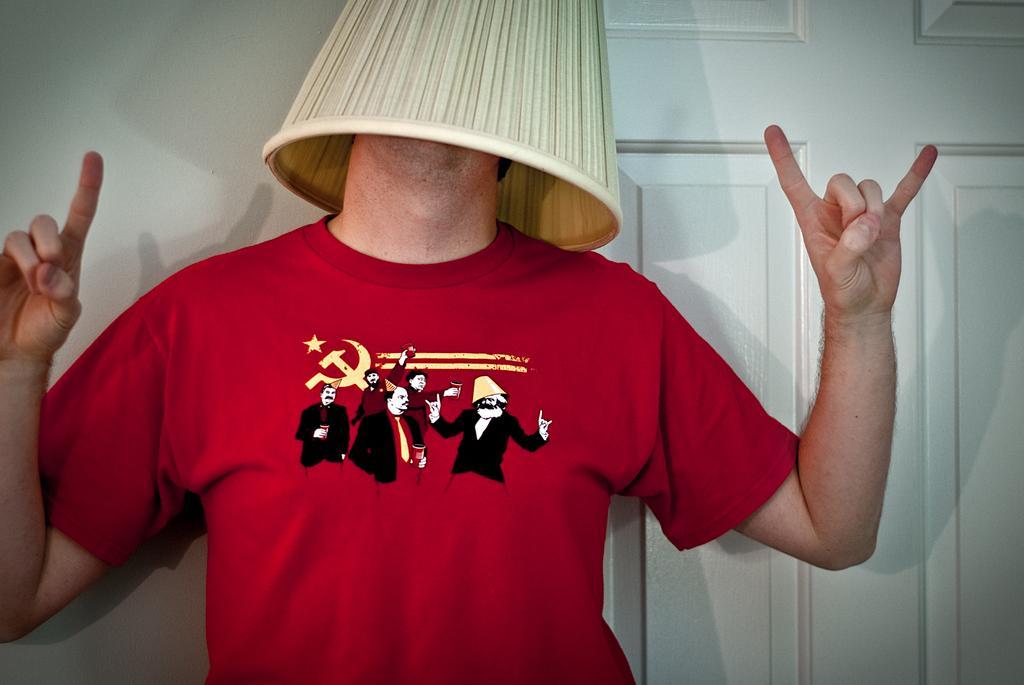How would you summarize this image in a sentence or two? In this image in the center there is a man standing and covering his face with an object which is white in colour. In the background there is a door and there is a wall. 